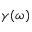<formula> <loc_0><loc_0><loc_500><loc_500>\gamma ( \omega )</formula> 